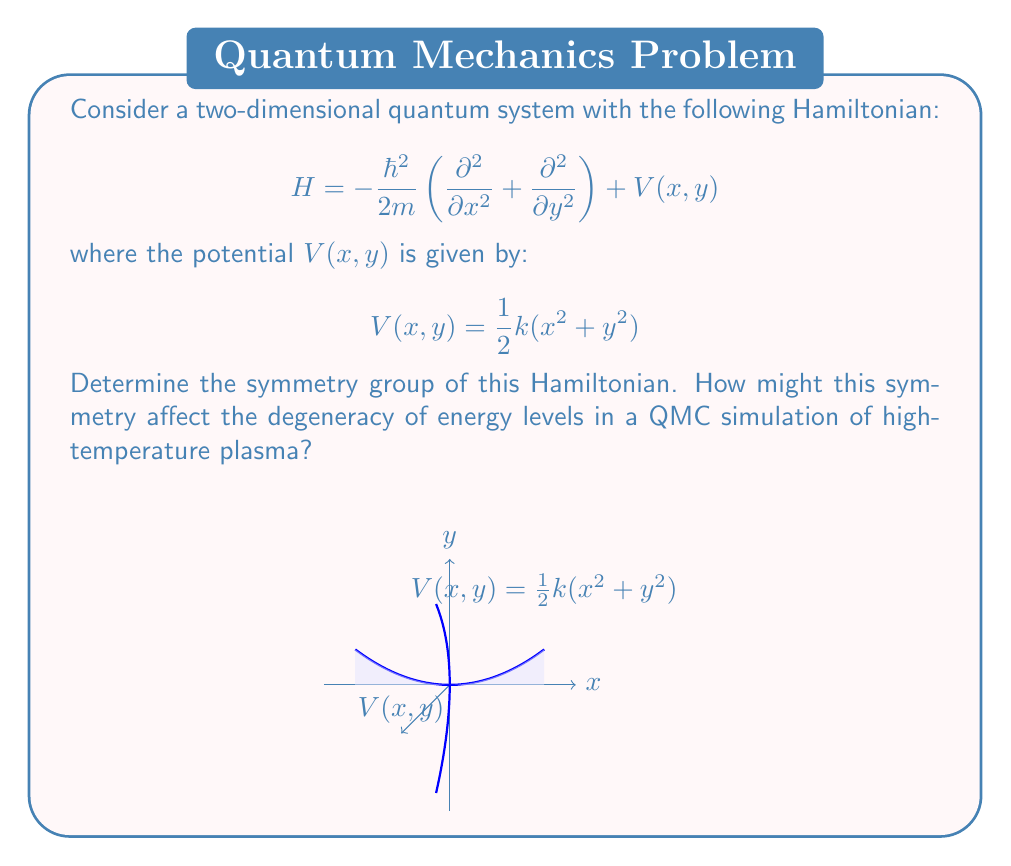Teach me how to tackle this problem. To determine the symmetry group of this Hamiltonian, we need to analyze its invariance under various transformations:

1. Kinetic Energy Term:
   The term $-\frac{\hbar^2}{2m}\left(\frac{\partial^2}{\partial x^2} + \frac{\partial^2}{\partial y^2}\right)$ is invariant under rotations in the x-y plane and reflections about any axis in this plane.

2. Potential Energy Term:
   $V(x,y) = \frac{1}{2}k(x^2 + y^2)$ is a radially symmetric function, invariant under rotations about the z-axis and reflections about any plane containing the z-axis.

3. Combined Symmetry:
   The full Hamiltonian is invariant under:
   a) Rotations about the z-axis (any angle)
   b) Reflections about any plane containing the z-axis
   c) Inversion through the origin $(x,y) \rightarrow (-x,-y)$

These symmetries correspond to the orthogonal group in two dimensions, O(2), which includes:
- SO(2): continuous rotations about the z-axis
- Reflections about any diameter of the x-y plane

The symmetry group is thus O(2).

Impact on QMC simulations:
1. Degeneracy: The O(2) symmetry implies that energy levels will be (2l+1)-fold degenerate, where l is the angular momentum quantum number. This degeneracy affects the energy spectrum in QMC simulations.

2. Computational Efficiency: Symmetry can be exploited to reduce the computational cost of QMC simulations by sampling only symmetry-inequivalent configurations.

3. Observables: Certain observables, such as angular momentum, will be conserved due to the rotational symmetry, which can be used as a check for the accuracy of QMC results.

4. High-Temperature Behavior: In high-temperature plasma, the O(2) symmetry may break down due to thermal fluctuations, affecting the degeneracy of energy levels and potentially leading to interesting phase transitions that can be studied using QMC methods.
Answer: O(2) 